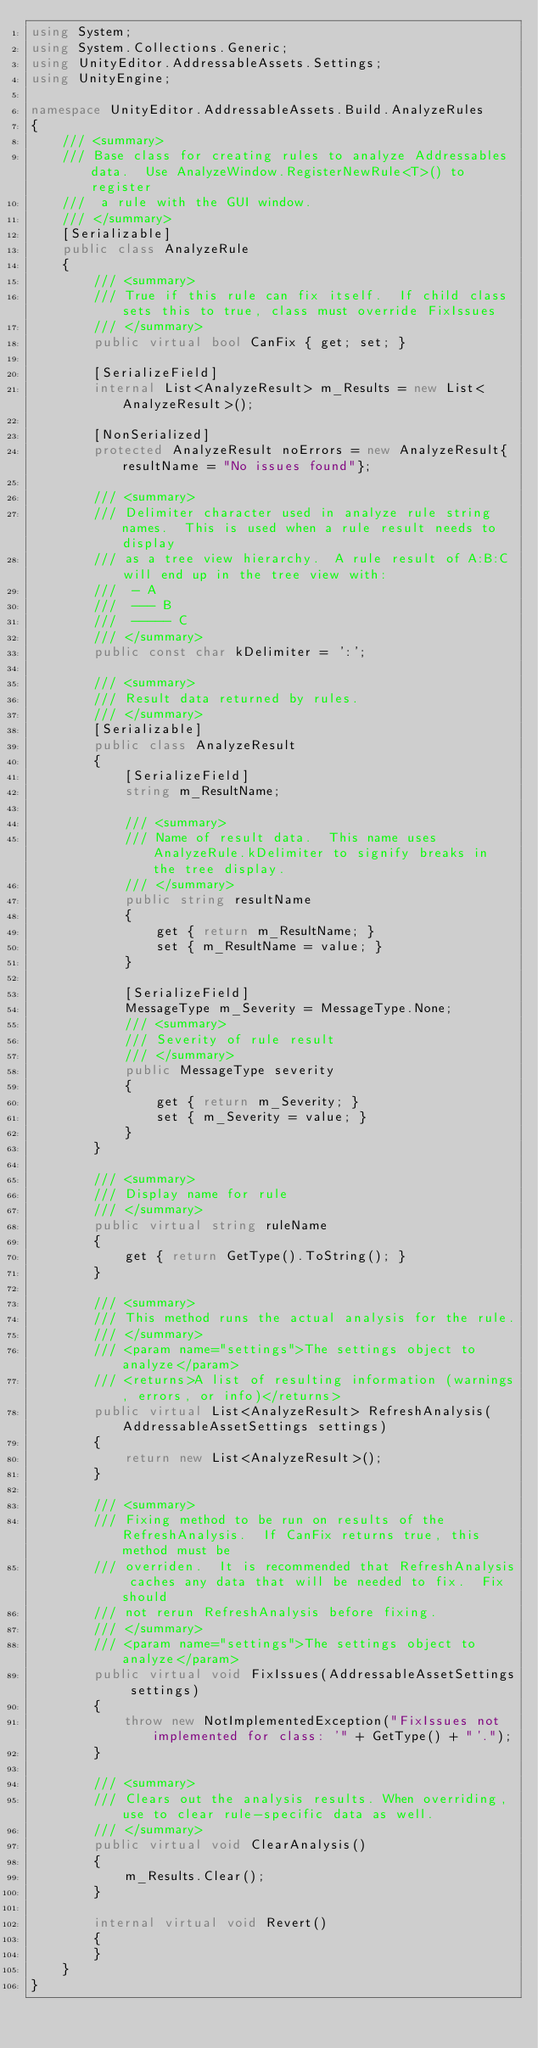<code> <loc_0><loc_0><loc_500><loc_500><_C#_>using System;
using System.Collections.Generic;
using UnityEditor.AddressableAssets.Settings;
using UnityEngine;

namespace UnityEditor.AddressableAssets.Build.AnalyzeRules
{
    /// <summary>
    /// Base class for creating rules to analyze Addressables data.  Use AnalyzeWindow.RegisterNewRule<T>() to register
    ///  a rule with the GUI window. 
    /// </summary>
    [Serializable]
    public class AnalyzeRule
    {
        /// <summary>
        /// True if this rule can fix itself.  If child class sets this to true, class must override FixIssues
        /// </summary>
        public virtual bool CanFix { get; set; }

        [SerializeField]
        internal List<AnalyzeResult> m_Results = new List<AnalyzeResult>();

        [NonSerialized]
        protected AnalyzeResult noErrors = new AnalyzeResult{resultName = "No issues found"};

        /// <summary>
        /// Delimiter character used in analyze rule string names.  This is used when a rule result needs to display
        /// as a tree view hierarchy.  A rule result of A:B:C will end up in the tree view with:
        ///  - A
        ///  --- B
        ///  ----- C
        /// </summary>
        public const char kDelimiter = ':';
        
        /// <summary>
        /// Result data returned by rules.  
        /// </summary>
        [Serializable]
        public class AnalyzeResult
        {
            [SerializeField]
            string m_ResultName;

            /// <summary>
            /// Name of result data.  This name uses AnalyzeRule.kDelimiter to signify breaks in the tree display.
            /// </summary>
            public string resultName
            {
                get { return m_ResultName; }
                set { m_ResultName = value; }
            }

            [SerializeField]
            MessageType m_Severity = MessageType.None;
            /// <summary>
            /// Severity of rule result
            /// </summary>
            public MessageType severity
            {
                get { return m_Severity; }
                set { m_Severity = value; }
            }
        }
        
        /// <summary>
        /// Display name for rule
        /// </summary>
        public virtual string ruleName
        {
            get { return GetType().ToString(); }
        }

        /// <summary>
        /// This method runs the actual analysis for the rule.   
        /// </summary>
        /// <param name="settings">The settings object to analyze</param>
        /// <returns>A list of resulting information (warnings, errors, or info)</returns>
        public virtual List<AnalyzeResult> RefreshAnalysis(AddressableAssetSettings settings)
        {
            return new List<AnalyzeResult>();
        }

        /// <summary>
        /// Fixing method to be run on results of the RefreshAnalysis.  If CanFix returns true, this method must be
        /// overriden.  It is recommended that RefreshAnalysis caches any data that will be needed to fix.  Fix should
        /// not rerun RefreshAnalysis before fixing. 
        /// </summary>
        /// <param name="settings">The settings object to analyze</param>
        public virtual void FixIssues(AddressableAssetSettings settings)
        {
            throw new NotImplementedException("FixIssues not implemented for class: '" + GetType() + "'."); 
        }

        /// <summary>
        /// Clears out the analysis results. When overriding, use to clear rule-specific data as well. 
        /// </summary>
        public virtual void ClearAnalysis()
        {
            m_Results.Clear();
        }

        internal virtual void Revert()
        {
        }
    }
}
</code> 